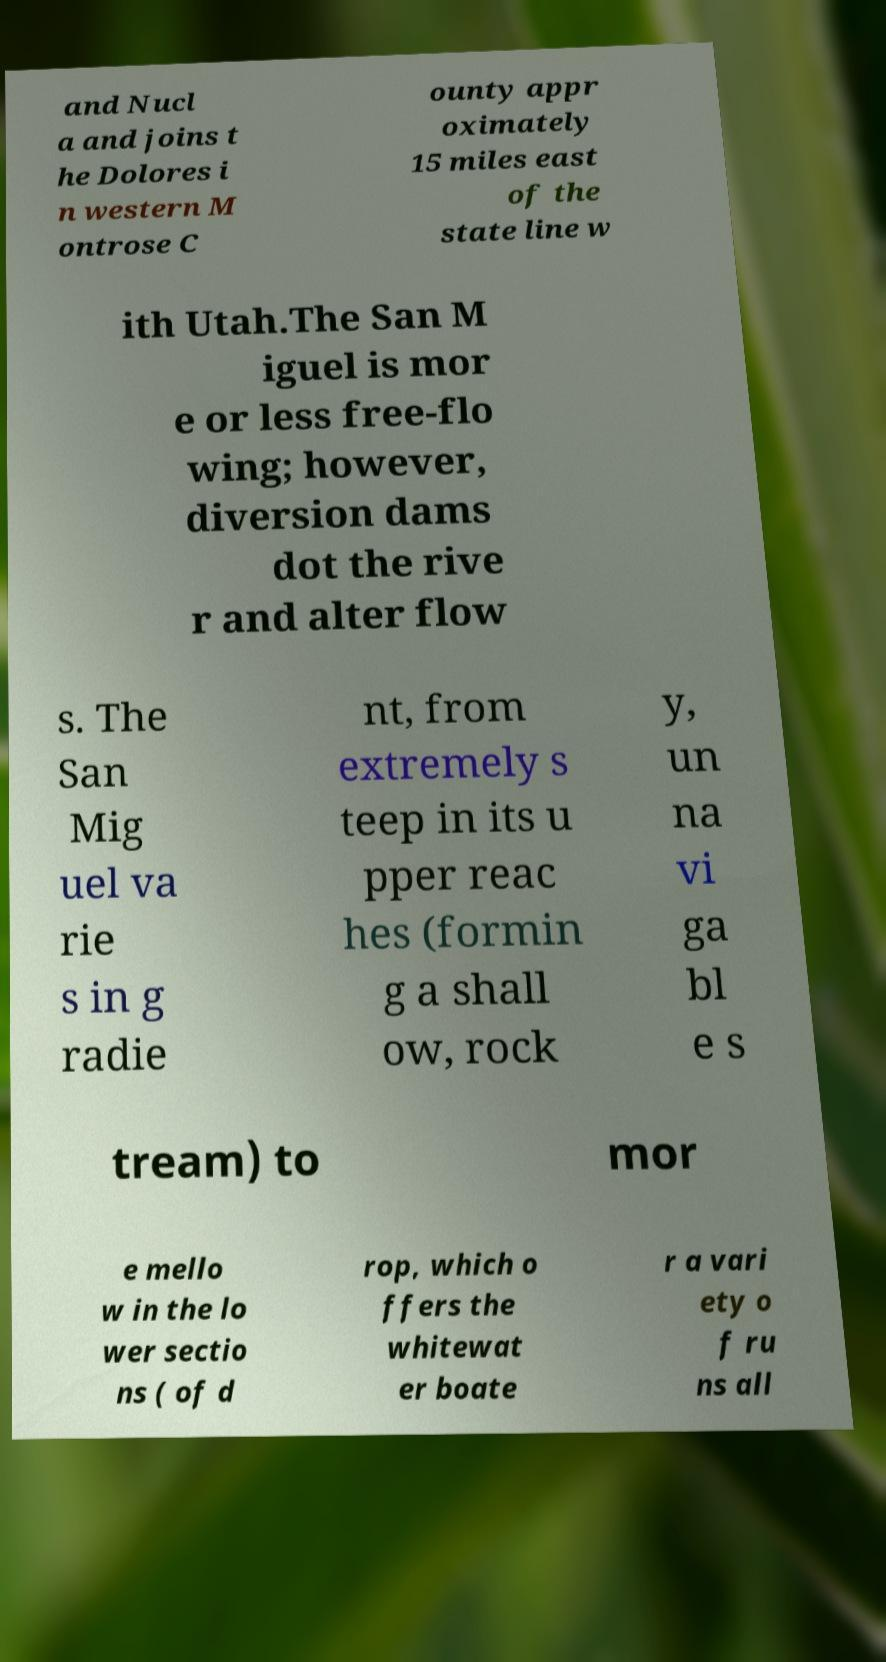Please read and relay the text visible in this image. What does it say? and Nucl a and joins t he Dolores i n western M ontrose C ounty appr oximately 15 miles east of the state line w ith Utah.The San M iguel is mor e or less free-flo wing; however, diversion dams dot the rive r and alter flow s. The San Mig uel va rie s in g radie nt, from extremely s teep in its u pper reac hes (formin g a shall ow, rock y, un na vi ga bl e s tream) to mor e mello w in the lo wer sectio ns ( of d rop, which o ffers the whitewat er boate r a vari ety o f ru ns all 